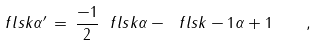Convert formula to latex. <formula><loc_0><loc_0><loc_500><loc_500>\ f l s { k } { \alpha } ^ { \prime } \, = \, \frac { - 1 } { 2 } \ f l s { k } { \alpha } - \ f l s { k - 1 } { { \alpha } + 1 } \quad ,</formula> 